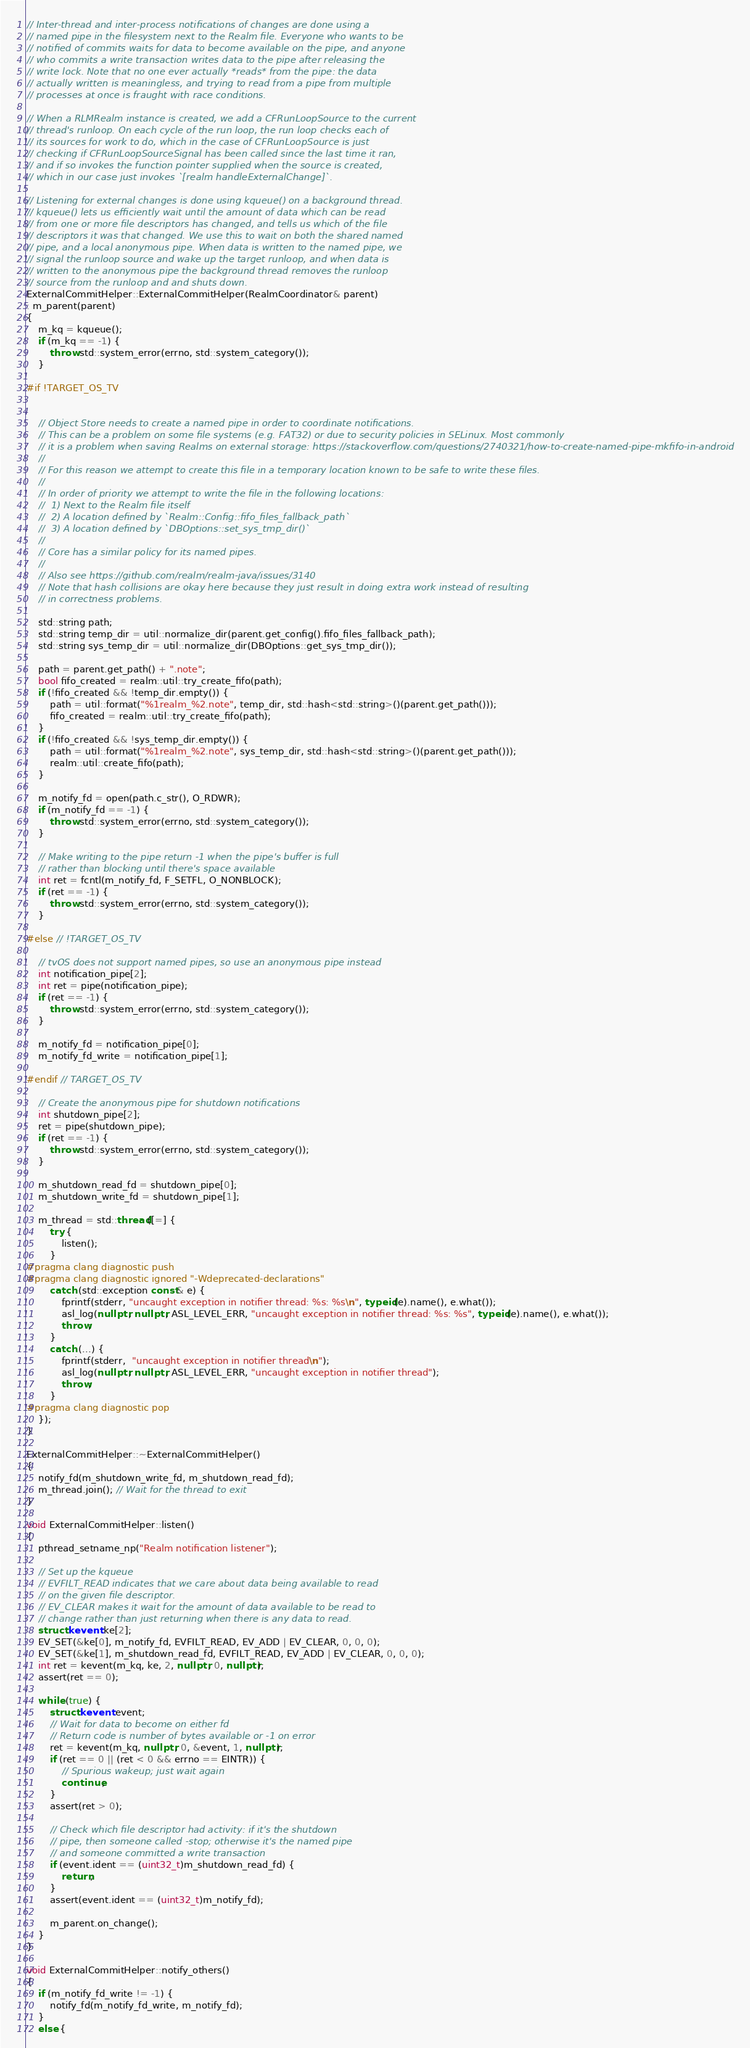Convert code to text. <code><loc_0><loc_0><loc_500><loc_500><_C++_>
// Inter-thread and inter-process notifications of changes are done using a
// named pipe in the filesystem next to the Realm file. Everyone who wants to be
// notified of commits waits for data to become available on the pipe, and anyone
// who commits a write transaction writes data to the pipe after releasing the
// write lock. Note that no one ever actually *reads* from the pipe: the data
// actually written is meaningless, and trying to read from a pipe from multiple
// processes at once is fraught with race conditions.

// When a RLMRealm instance is created, we add a CFRunLoopSource to the current
// thread's runloop. On each cycle of the run loop, the run loop checks each of
// its sources for work to do, which in the case of CFRunLoopSource is just
// checking if CFRunLoopSourceSignal has been called since the last time it ran,
// and if so invokes the function pointer supplied when the source is created,
// which in our case just invokes `[realm handleExternalChange]`.

// Listening for external changes is done using kqueue() on a background thread.
// kqueue() lets us efficiently wait until the amount of data which can be read
// from one or more file descriptors has changed, and tells us which of the file
// descriptors it was that changed. We use this to wait on both the shared named
// pipe, and a local anonymous pipe. When data is written to the named pipe, we
// signal the runloop source and wake up the target runloop, and when data is
// written to the anonymous pipe the background thread removes the runloop
// source from the runloop and and shuts down.
ExternalCommitHelper::ExternalCommitHelper(RealmCoordinator& parent)
: m_parent(parent)
{
    m_kq = kqueue();
    if (m_kq == -1) {
        throw std::system_error(errno, std::system_category());
    }

#if !TARGET_OS_TV


    // Object Store needs to create a named pipe in order to coordinate notifications.
    // This can be a problem on some file systems (e.g. FAT32) or due to security policies in SELinux. Most commonly
    // it is a problem when saving Realms on external storage: https://stackoverflow.com/questions/2740321/how-to-create-named-pipe-mkfifo-in-android
    //
    // For this reason we attempt to create this file in a temporary location known to be safe to write these files.
    //
    // In order of priority we attempt to write the file in the following locations:
    //  1) Next to the Realm file itself
    //  2) A location defined by `Realm::Config::fifo_files_fallback_path`
    //  3) A location defined by `DBOptions::set_sys_tmp_dir()`
    //
    // Core has a similar policy for its named pipes.
    //
    // Also see https://github.com/realm/realm-java/issues/3140
    // Note that hash collisions are okay here because they just result in doing extra work instead of resulting
    // in correctness problems.

    std::string path;
    std::string temp_dir = util::normalize_dir(parent.get_config().fifo_files_fallback_path);
    std::string sys_temp_dir = util::normalize_dir(DBOptions::get_sys_tmp_dir());

    path = parent.get_path() + ".note";
    bool fifo_created = realm::util::try_create_fifo(path);
    if (!fifo_created && !temp_dir.empty()) {
        path = util::format("%1realm_%2.note", temp_dir, std::hash<std::string>()(parent.get_path()));
        fifo_created = realm::util::try_create_fifo(path);
    }
    if (!fifo_created && !sys_temp_dir.empty()) {
        path = util::format("%1realm_%2.note", sys_temp_dir, std::hash<std::string>()(parent.get_path()));
        realm::util::create_fifo(path);
    }

    m_notify_fd = open(path.c_str(), O_RDWR);
    if (m_notify_fd == -1) {
        throw std::system_error(errno, std::system_category());
    }

    // Make writing to the pipe return -1 when the pipe's buffer is full
    // rather than blocking until there's space available
    int ret = fcntl(m_notify_fd, F_SETFL, O_NONBLOCK);
    if (ret == -1) {
        throw std::system_error(errno, std::system_category());
    }

#else // !TARGET_OS_TV

    // tvOS does not support named pipes, so use an anonymous pipe instead
    int notification_pipe[2];
    int ret = pipe(notification_pipe);
    if (ret == -1) {
        throw std::system_error(errno, std::system_category());
    }

    m_notify_fd = notification_pipe[0];
    m_notify_fd_write = notification_pipe[1];

#endif // TARGET_OS_TV

    // Create the anonymous pipe for shutdown notifications
    int shutdown_pipe[2];
    ret = pipe(shutdown_pipe);
    if (ret == -1) {
        throw std::system_error(errno, std::system_category());
    }

    m_shutdown_read_fd = shutdown_pipe[0];
    m_shutdown_write_fd = shutdown_pipe[1];

    m_thread = std::thread([=] {
        try {
            listen();
        }
#pragma clang diagnostic push
#pragma clang diagnostic ignored "-Wdeprecated-declarations"
        catch (std::exception const& e) {
            fprintf(stderr, "uncaught exception in notifier thread: %s: %s\n", typeid(e).name(), e.what());
            asl_log(nullptr, nullptr, ASL_LEVEL_ERR, "uncaught exception in notifier thread: %s: %s", typeid(e).name(), e.what());
            throw;
        }
        catch (...) {
            fprintf(stderr,  "uncaught exception in notifier thread\n");
            asl_log(nullptr, nullptr, ASL_LEVEL_ERR, "uncaught exception in notifier thread");
            throw;
        }
#pragma clang diagnostic pop
    });
}

ExternalCommitHelper::~ExternalCommitHelper()
{
    notify_fd(m_shutdown_write_fd, m_shutdown_read_fd);
    m_thread.join(); // Wait for the thread to exit
}

void ExternalCommitHelper::listen()
{
    pthread_setname_np("Realm notification listener");

    // Set up the kqueue
    // EVFILT_READ indicates that we care about data being available to read
    // on the given file descriptor.
    // EV_CLEAR makes it wait for the amount of data available to be read to
    // change rather than just returning when there is any data to read.
    struct kevent ke[2];
    EV_SET(&ke[0], m_notify_fd, EVFILT_READ, EV_ADD | EV_CLEAR, 0, 0, 0);
    EV_SET(&ke[1], m_shutdown_read_fd, EVFILT_READ, EV_ADD | EV_CLEAR, 0, 0, 0);
    int ret = kevent(m_kq, ke, 2, nullptr, 0, nullptr);
    assert(ret == 0);

    while (true) {
        struct kevent event;
        // Wait for data to become on either fd
        // Return code is number of bytes available or -1 on error
        ret = kevent(m_kq, nullptr, 0, &event, 1, nullptr);
        if (ret == 0 || (ret < 0 && errno == EINTR)) {
            // Spurious wakeup; just wait again
            continue;
        }
        assert(ret > 0);

        // Check which file descriptor had activity: if it's the shutdown
        // pipe, then someone called -stop; otherwise it's the named pipe
        // and someone committed a write transaction
        if (event.ident == (uint32_t)m_shutdown_read_fd) {
            return;
        }
        assert(event.ident == (uint32_t)m_notify_fd);

        m_parent.on_change();
    }
}

void ExternalCommitHelper::notify_others()
{
    if (m_notify_fd_write != -1) {
        notify_fd(m_notify_fd_write, m_notify_fd);
    }
    else {</code> 